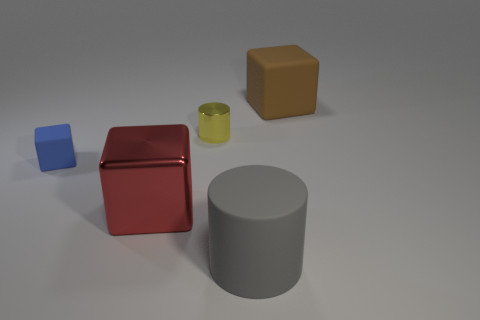How many objects are there in total in this image? There are four objects in total in this image: a blue rubber block, a red metal cube, a yellow metal object, and a gray cylindrical object. Can you describe the texture of the objects? Certainly! The blue rubber block and the yellow metal object have a smooth texture. The red metal cube appears to have a slightly reflective texture, indicative of a polished surface, while the gray cylinder looks to have a matte finish. 